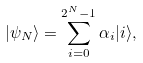Convert formula to latex. <formula><loc_0><loc_0><loc_500><loc_500>| \psi _ { N } \rangle = \sum _ { i = 0 } ^ { 2 ^ { N } - 1 } \alpha _ { i } | i \rangle ,</formula> 